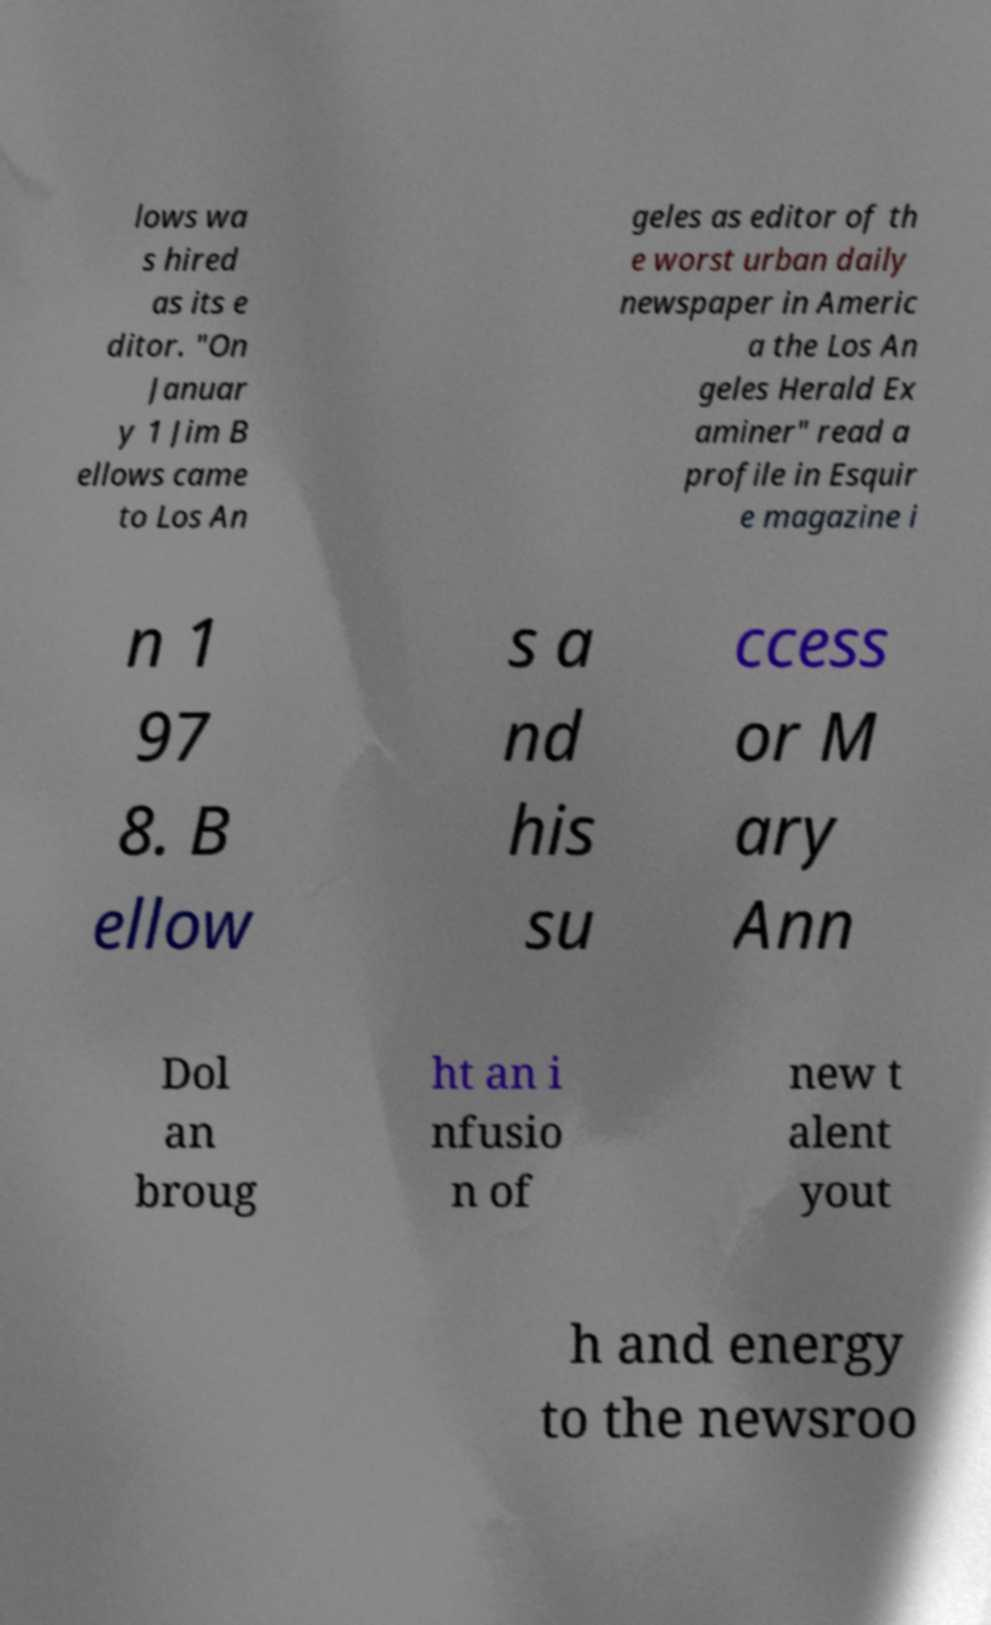Can you read and provide the text displayed in the image?This photo seems to have some interesting text. Can you extract and type it out for me? lows wa s hired as its e ditor. "On Januar y 1 Jim B ellows came to Los An geles as editor of th e worst urban daily newspaper in Americ a the Los An geles Herald Ex aminer" read a profile in Esquir e magazine i n 1 97 8. B ellow s a nd his su ccess or M ary Ann Dol an broug ht an i nfusio n of new t alent yout h and energy to the newsroo 